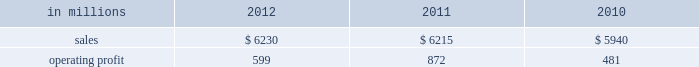Printing papers demand for printing papers products is closely corre- lated with changes in commercial printing and advertising activity , direct mail volumes and , for uncoated cut-size products , with changes in white- collar employment levels that affect the usage of copy and laser printer paper .
Pulp is further affected by changes in currency rates that can enhance or disadvantage producers in different geographic regions .
Principal cost drivers include manufacturing efficiency , raw material and energy costs and freight costs .
Pr int ing papers net sales for 2012 were about flat with 2011 and increased 5% ( 5 % ) from 2010 .
Operat- ing profits in 2012 were 31% ( 31 % ) lower than in 2011 , but 25% ( 25 % ) higher than in 2010 .
Excluding facility closure costs and impairment costs , operating profits in 2012 were 30% ( 30 % ) lower than in 2011 and 25% ( 25 % ) lower than in 2010 .
Benefits from higher sales volumes ( $ 58 mil- lion ) were more than offset by lower sales price real- izations and an unfavorable product mix ( $ 233 million ) , higher operating costs ( $ 30 million ) , higher maintenance outage costs ( $ 17 million ) , higher input costs ( $ 32 million ) and other items ( $ 6 million ) .
In addition , operating profits in 2011 included a $ 24 million gain related to the announced repurposing of our franklin , virginia mill to produce fluff pulp and an $ 11 million impairment charge related to our inverurie , scotland mill that was closed in 2009 .
Printing papers .
North american pr int ing papers net sales were $ 2.7 billion in 2012 , $ 2.8 billion in 2011 and $ 2.8 billion in 2010 .
Operating profits in 2012 were $ 331 million compared with $ 423 million ( $ 399 million excluding a $ 24 million gain associated with the repurposing of our franklin , virginia mill ) in 2011 and $ 18 million ( $ 333 million excluding facility clo- sure costs ) in 2010 .
Sales volumes in 2012 were flat with 2011 .
Average sales margins were lower primarily due to lower export sales prices and higher export sales volume .
Input costs were higher for wood and chemicals , but were partially offset by lower purchased pulp costs .
Freight costs increased due to higher oil prices .
Manufacturing operating costs were favorable reflecting strong mill performance .
Planned main- tenance downtime costs were slightly higher in 2012 .
No market-related downtime was taken in either 2012 or 2011 .
Entering the first quarter of 2013 , sales volumes are expected to increase compared with the fourth quar- ter of 2012 reflecting seasonally stronger demand .
Average sales price realizations are expected to be relatively flat as sales price realizations for domestic and export uncoated freesheet roll and cutsize paper should be stable .
Input costs should increase for energy , chemicals and wood .
Planned maintenance downtime costs are expected to be about $ 19 million lower with an outage scheduled at our georgetown mill versus outages at our courtland and eastover mills in the fourth quarter of 2012 .
Braz i l ian papers net sales for 2012 were $ 1.1 bil- lion compared with $ 1.2 billion in 2011 and $ 1.1 bil- lion in 2010 .
Operating profits for 2012 were $ 163 million compared with $ 169 million in 2011 and $ 159 million in 2010 .
Sales volumes in 2012 were higher than in 2011 as international paper improved its segment position in the brazilian market despite weaker year-over-year conditions in most markets .
Average sales price realizations improved for domestic uncoated freesheet paper , but the benefit was more than offset by declining prices for exported paper .
Margins were favorably affected by an increased proportion of sales to the higher- margin domestic market .
Raw material costs increased for wood and chemicals , but costs for purchased pulp decreased .
Operating costs and planned maintenance downtime costs were lower than in 2011 .
Looking ahead to 2013 , sales volumes in the first quarter are expected to be lower than in the fourth quarter of 2012 due to seasonally weaker customer demand for uncoated freesheet paper .
Average sales price realizations are expected to increase in the brazilian domestic market due to the realization of an announced sales price increase for uncoated free- sheet paper , but the benefit should be partially offset by pricing pressures in export markets .
Average sales margins are expected to be negatively impacted by a less favorable geographic mix .
Input costs are expected to be about flat due to lower energy costs being offset by higher costs for wood , purchased pulp , chemicals and utilities .
Planned maintenance outage costs should be $ 4 million lower with no outages scheduled in the first quarter .
Operating costs should be favorably impacted by the savings generated by the start-up of a new biomass boiler at the mogi guacu mill .
European papers net sales in 2012 were $ 1.4 bil- lion compared with $ 1.4 billion in 2011 and $ 1.3 bil- lion in 2010 .
Operating profits in 2012 were $ 179 million compared with $ 196 million ( $ 207 million excluding asset impairment charges related to our inverurie , scotland mill which was closed in 2009 ) in 2011 and $ 197 million ( $ 199 million excluding an asset impairment charge ) in 2010 .
Sales volumes in 2012 compared with 2011 were higher for uncoated freesheet paper in both europe and russia , while sales volumes for pulp were lower in both regions .
Average sales price realizations for uncoated .
What percentage of printing paper sales where north american printing papers sales in 2011? 
Computations: ((2.8 * 1000) / 6215)
Answer: 0.45052. 